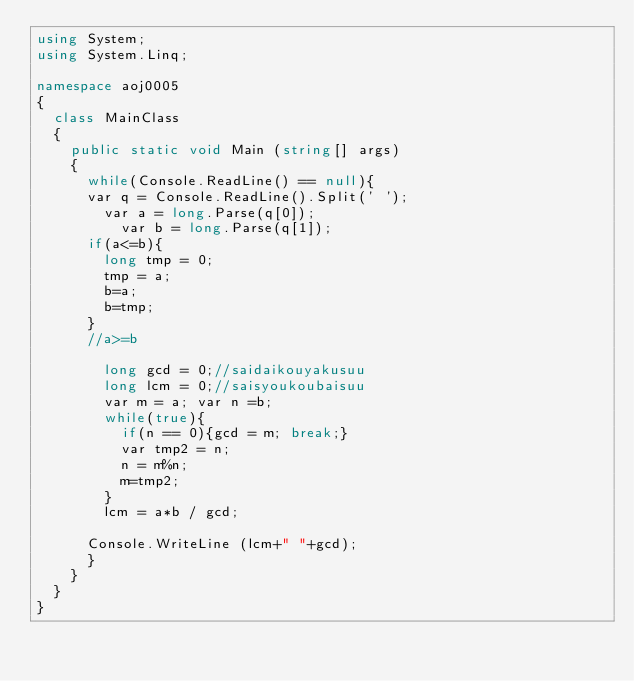<code> <loc_0><loc_0><loc_500><loc_500><_C#_>using System;
using System.Linq;

namespace aoj0005
{
	class MainClass
	{
		public static void Main (string[] args)
		{
			while(Console.ReadLine() == null){
			var q = Console.ReadLine().Split(' ');
				var a = long.Parse(q[0]);
			    var b = long.Parse(q[1]);
			if(a<=b){
				long tmp = 0;
				tmp = a;
				b=a;
				b=tmp;
			}
			//a>=b
				
				long gcd = 0;//saidaikouyakusuu
				long lcm = 0;//saisyoukoubaisuu
				var m = a; var n =b;
				while(true){
					if(n == 0){gcd = m; break;}
					var tmp2 = n;
					n = m%n;
					m=tmp2;
				}
				lcm = a*b / gcd;
				
			Console.WriteLine (lcm+" "+gcd);
			}
		}
	}
}</code> 